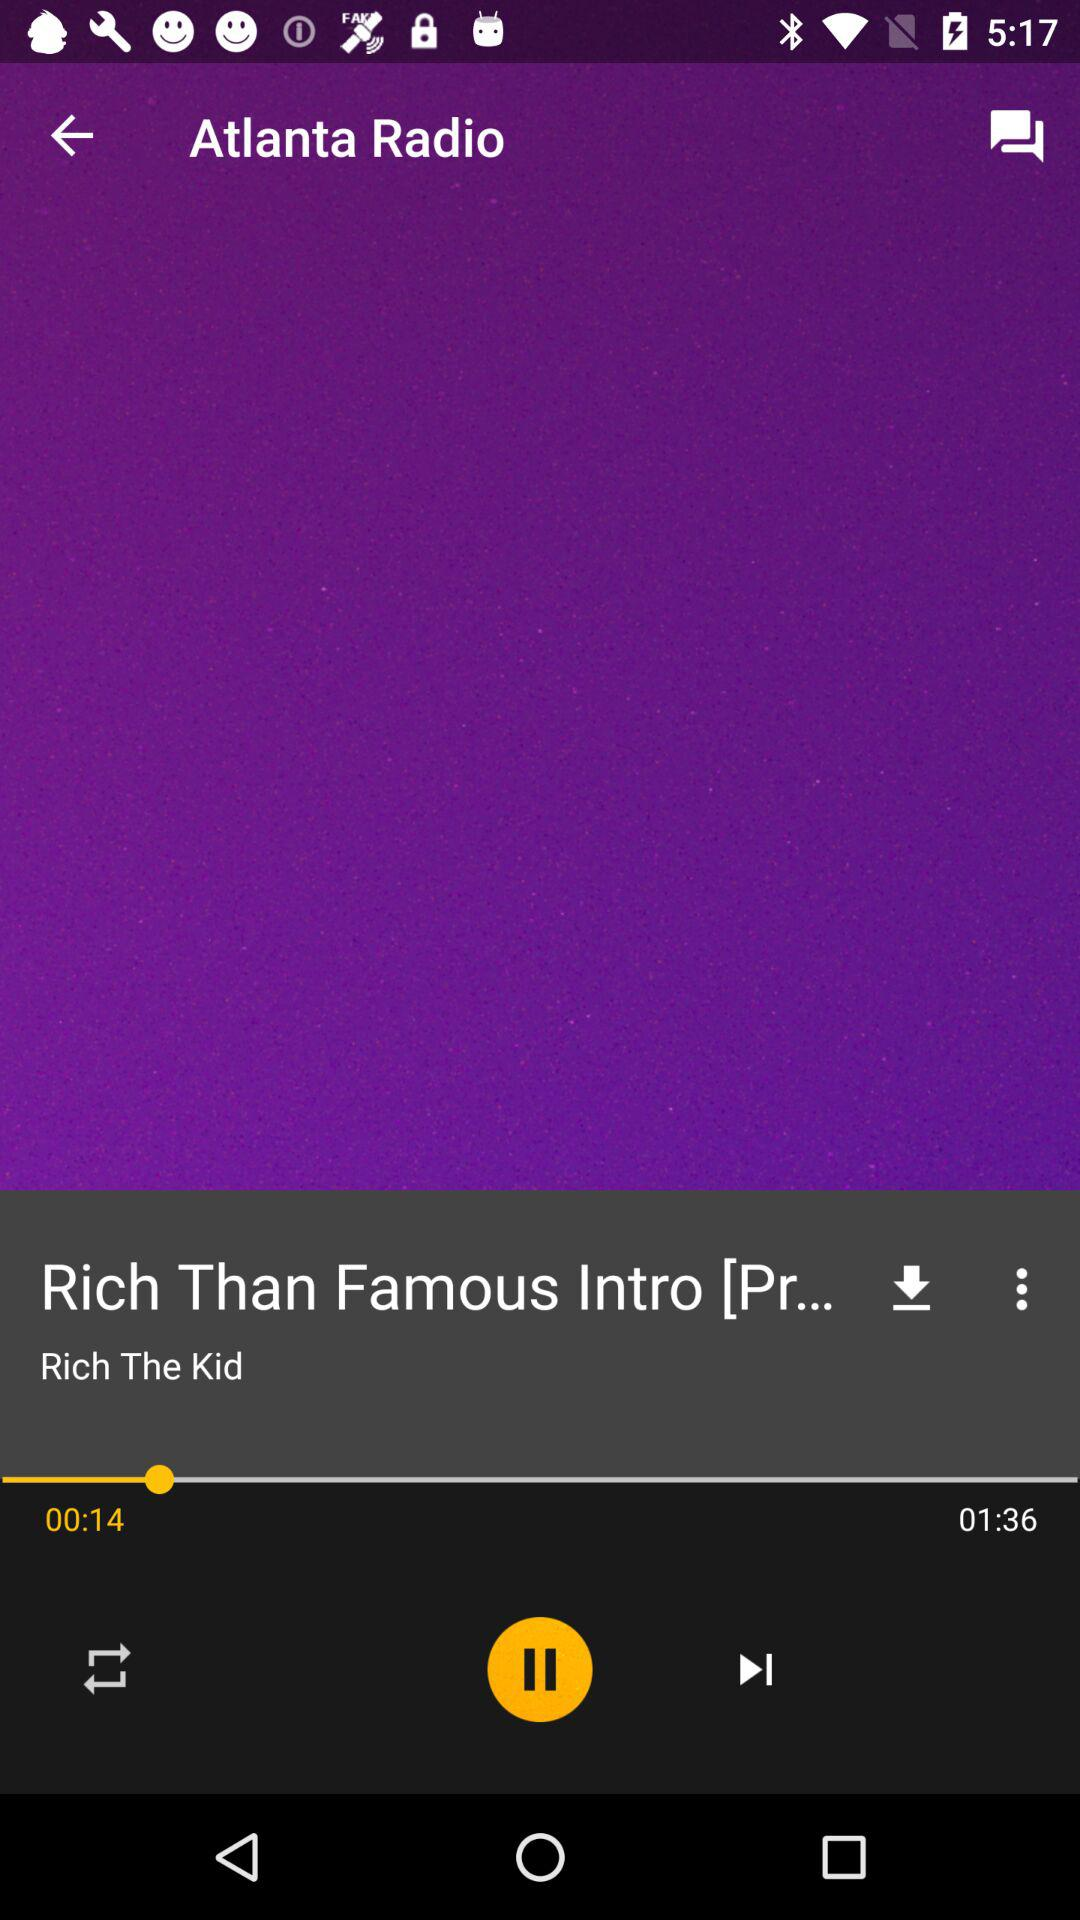How much song has been played? The song is played for about 14 seconds. 